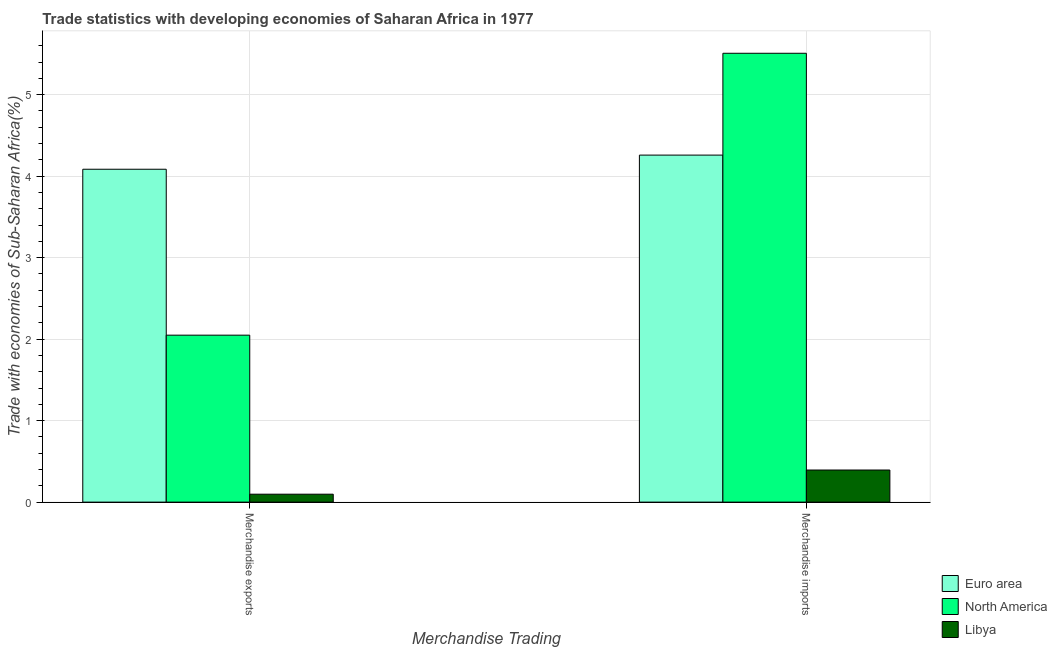How many groups of bars are there?
Offer a very short reply. 2. How many bars are there on the 1st tick from the right?
Your answer should be very brief. 3. What is the merchandise imports in Euro area?
Offer a terse response. 4.26. Across all countries, what is the maximum merchandise imports?
Make the answer very short. 5.51. Across all countries, what is the minimum merchandise imports?
Your answer should be very brief. 0.39. In which country was the merchandise exports minimum?
Keep it short and to the point. Libya. What is the total merchandise exports in the graph?
Make the answer very short. 6.23. What is the difference between the merchandise exports in Euro area and that in Libya?
Keep it short and to the point. 3.99. What is the difference between the merchandise imports in North America and the merchandise exports in Euro area?
Your response must be concise. 1.42. What is the average merchandise imports per country?
Your answer should be very brief. 3.39. What is the difference between the merchandise exports and merchandise imports in Libya?
Your response must be concise. -0.3. In how many countries, is the merchandise exports greater than 3.2 %?
Your answer should be very brief. 1. What is the ratio of the merchandise imports in Euro area to that in North America?
Keep it short and to the point. 0.77. In how many countries, is the merchandise imports greater than the average merchandise imports taken over all countries?
Keep it short and to the point. 2. What does the 1st bar from the right in Merchandise imports represents?
Your response must be concise. Libya. Are all the bars in the graph horizontal?
Your response must be concise. No. What is the difference between two consecutive major ticks on the Y-axis?
Keep it short and to the point. 1. Where does the legend appear in the graph?
Your answer should be very brief. Bottom right. How many legend labels are there?
Provide a short and direct response. 3. What is the title of the graph?
Your answer should be compact. Trade statistics with developing economies of Saharan Africa in 1977. Does "Belgium" appear as one of the legend labels in the graph?
Offer a very short reply. No. What is the label or title of the X-axis?
Your answer should be very brief. Merchandise Trading. What is the label or title of the Y-axis?
Provide a short and direct response. Trade with economies of Sub-Saharan Africa(%). What is the Trade with economies of Sub-Saharan Africa(%) in Euro area in Merchandise exports?
Your answer should be very brief. 4.08. What is the Trade with economies of Sub-Saharan Africa(%) in North America in Merchandise exports?
Your response must be concise. 2.05. What is the Trade with economies of Sub-Saharan Africa(%) in Libya in Merchandise exports?
Give a very brief answer. 0.1. What is the Trade with economies of Sub-Saharan Africa(%) of Euro area in Merchandise imports?
Keep it short and to the point. 4.26. What is the Trade with economies of Sub-Saharan Africa(%) in North America in Merchandise imports?
Keep it short and to the point. 5.51. What is the Trade with economies of Sub-Saharan Africa(%) of Libya in Merchandise imports?
Provide a succinct answer. 0.39. Across all Merchandise Trading, what is the maximum Trade with economies of Sub-Saharan Africa(%) in Euro area?
Offer a very short reply. 4.26. Across all Merchandise Trading, what is the maximum Trade with economies of Sub-Saharan Africa(%) of North America?
Offer a very short reply. 5.51. Across all Merchandise Trading, what is the maximum Trade with economies of Sub-Saharan Africa(%) of Libya?
Your answer should be very brief. 0.39. Across all Merchandise Trading, what is the minimum Trade with economies of Sub-Saharan Africa(%) in Euro area?
Your answer should be compact. 4.08. Across all Merchandise Trading, what is the minimum Trade with economies of Sub-Saharan Africa(%) of North America?
Give a very brief answer. 2.05. Across all Merchandise Trading, what is the minimum Trade with economies of Sub-Saharan Africa(%) in Libya?
Offer a terse response. 0.1. What is the total Trade with economies of Sub-Saharan Africa(%) in Euro area in the graph?
Make the answer very short. 8.34. What is the total Trade with economies of Sub-Saharan Africa(%) of North America in the graph?
Offer a very short reply. 7.56. What is the total Trade with economies of Sub-Saharan Africa(%) of Libya in the graph?
Make the answer very short. 0.49. What is the difference between the Trade with economies of Sub-Saharan Africa(%) of Euro area in Merchandise exports and that in Merchandise imports?
Provide a succinct answer. -0.17. What is the difference between the Trade with economies of Sub-Saharan Africa(%) of North America in Merchandise exports and that in Merchandise imports?
Provide a succinct answer. -3.46. What is the difference between the Trade with economies of Sub-Saharan Africa(%) in Libya in Merchandise exports and that in Merchandise imports?
Your response must be concise. -0.3. What is the difference between the Trade with economies of Sub-Saharan Africa(%) in Euro area in Merchandise exports and the Trade with economies of Sub-Saharan Africa(%) in North America in Merchandise imports?
Your answer should be very brief. -1.42. What is the difference between the Trade with economies of Sub-Saharan Africa(%) of Euro area in Merchandise exports and the Trade with economies of Sub-Saharan Africa(%) of Libya in Merchandise imports?
Your response must be concise. 3.69. What is the difference between the Trade with economies of Sub-Saharan Africa(%) in North America in Merchandise exports and the Trade with economies of Sub-Saharan Africa(%) in Libya in Merchandise imports?
Your answer should be very brief. 1.65. What is the average Trade with economies of Sub-Saharan Africa(%) in Euro area per Merchandise Trading?
Offer a very short reply. 4.17. What is the average Trade with economies of Sub-Saharan Africa(%) of North America per Merchandise Trading?
Ensure brevity in your answer.  3.78. What is the average Trade with economies of Sub-Saharan Africa(%) of Libya per Merchandise Trading?
Your answer should be very brief. 0.25. What is the difference between the Trade with economies of Sub-Saharan Africa(%) in Euro area and Trade with economies of Sub-Saharan Africa(%) in North America in Merchandise exports?
Keep it short and to the point. 2.04. What is the difference between the Trade with economies of Sub-Saharan Africa(%) in Euro area and Trade with economies of Sub-Saharan Africa(%) in Libya in Merchandise exports?
Offer a very short reply. 3.99. What is the difference between the Trade with economies of Sub-Saharan Africa(%) of North America and Trade with economies of Sub-Saharan Africa(%) of Libya in Merchandise exports?
Offer a terse response. 1.95. What is the difference between the Trade with economies of Sub-Saharan Africa(%) of Euro area and Trade with economies of Sub-Saharan Africa(%) of North America in Merchandise imports?
Your response must be concise. -1.25. What is the difference between the Trade with economies of Sub-Saharan Africa(%) in Euro area and Trade with economies of Sub-Saharan Africa(%) in Libya in Merchandise imports?
Provide a short and direct response. 3.86. What is the difference between the Trade with economies of Sub-Saharan Africa(%) of North America and Trade with economies of Sub-Saharan Africa(%) of Libya in Merchandise imports?
Your response must be concise. 5.11. What is the ratio of the Trade with economies of Sub-Saharan Africa(%) in Euro area in Merchandise exports to that in Merchandise imports?
Your response must be concise. 0.96. What is the ratio of the Trade with economies of Sub-Saharan Africa(%) of North America in Merchandise exports to that in Merchandise imports?
Offer a terse response. 0.37. What is the ratio of the Trade with economies of Sub-Saharan Africa(%) in Libya in Merchandise exports to that in Merchandise imports?
Your answer should be very brief. 0.25. What is the difference between the highest and the second highest Trade with economies of Sub-Saharan Africa(%) of Euro area?
Your answer should be very brief. 0.17. What is the difference between the highest and the second highest Trade with economies of Sub-Saharan Africa(%) in North America?
Provide a succinct answer. 3.46. What is the difference between the highest and the second highest Trade with economies of Sub-Saharan Africa(%) of Libya?
Keep it short and to the point. 0.3. What is the difference between the highest and the lowest Trade with economies of Sub-Saharan Africa(%) in Euro area?
Your response must be concise. 0.17. What is the difference between the highest and the lowest Trade with economies of Sub-Saharan Africa(%) in North America?
Ensure brevity in your answer.  3.46. What is the difference between the highest and the lowest Trade with economies of Sub-Saharan Africa(%) of Libya?
Provide a succinct answer. 0.3. 